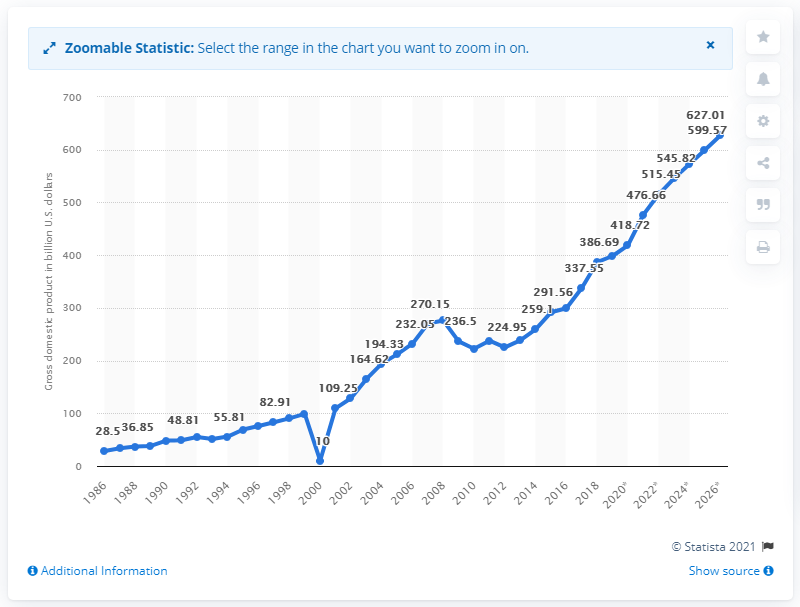Mention a couple of crucial points in this snapshot. In 2019, the gross domestic product of Ireland was 398.38. 